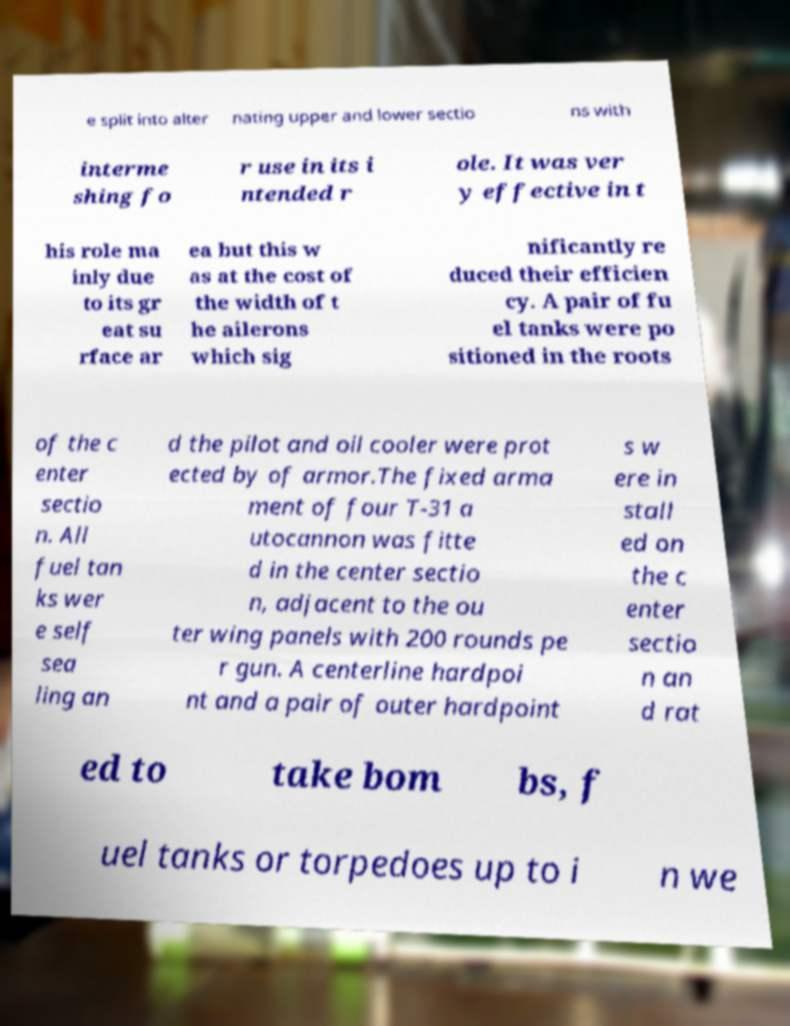What messages or text are displayed in this image? I need them in a readable, typed format. e split into alter nating upper and lower sectio ns with interme shing fo r use in its i ntended r ole. It was ver y effective in t his role ma inly due to its gr eat su rface ar ea but this w as at the cost of the width of t he ailerons which sig nificantly re duced their efficien cy. A pair of fu el tanks were po sitioned in the roots of the c enter sectio n. All fuel tan ks wer e self sea ling an d the pilot and oil cooler were prot ected by of armor.The fixed arma ment of four T-31 a utocannon was fitte d in the center sectio n, adjacent to the ou ter wing panels with 200 rounds pe r gun. A centerline hardpoi nt and a pair of outer hardpoint s w ere in stall ed on the c enter sectio n an d rat ed to take bom bs, f uel tanks or torpedoes up to i n we 